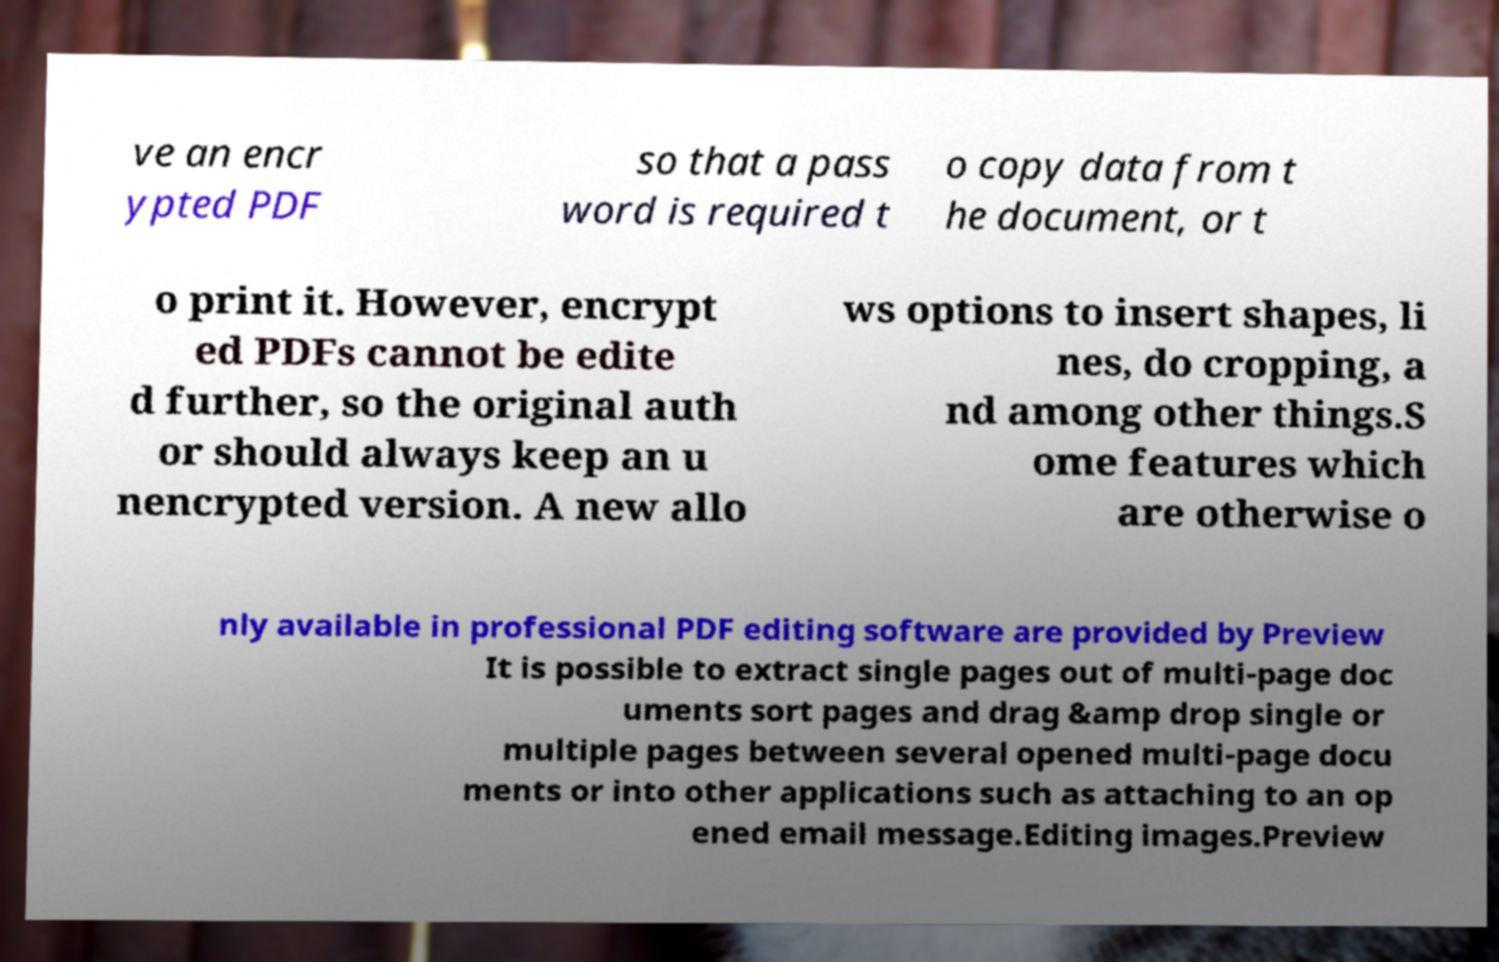Can you accurately transcribe the text from the provided image for me? ve an encr ypted PDF so that a pass word is required t o copy data from t he document, or t o print it. However, encrypt ed PDFs cannot be edite d further, so the original auth or should always keep an u nencrypted version. A new allo ws options to insert shapes, li nes, do cropping, a nd among other things.S ome features which are otherwise o nly available in professional PDF editing software are provided by Preview It is possible to extract single pages out of multi-page doc uments sort pages and drag &amp drop single or multiple pages between several opened multi-page docu ments or into other applications such as attaching to an op ened email message.Editing images.Preview 